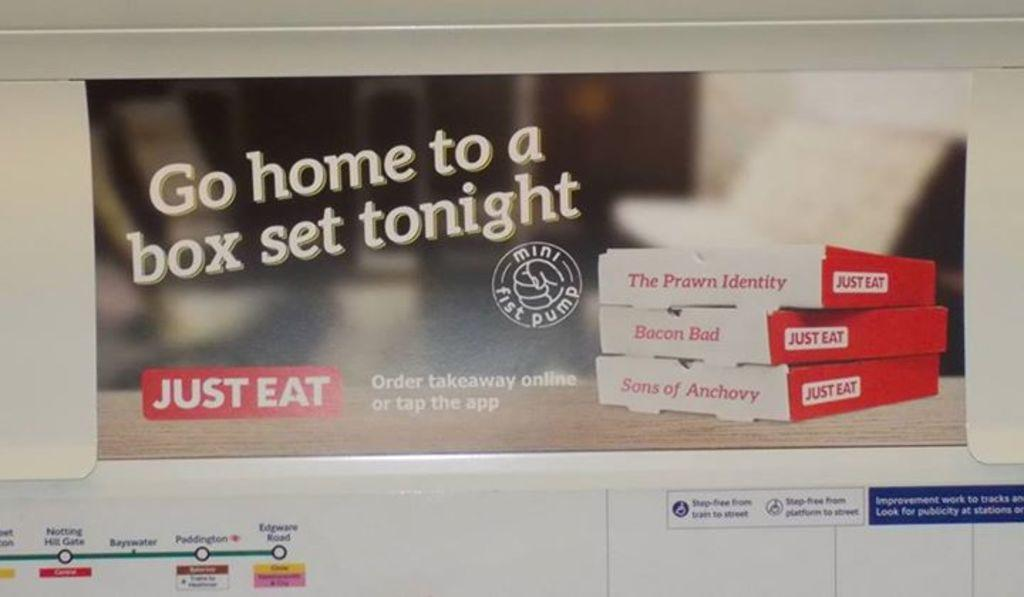<image>
Describe the image concisely. An advertisement suggests that we go home to a box set tonight. 